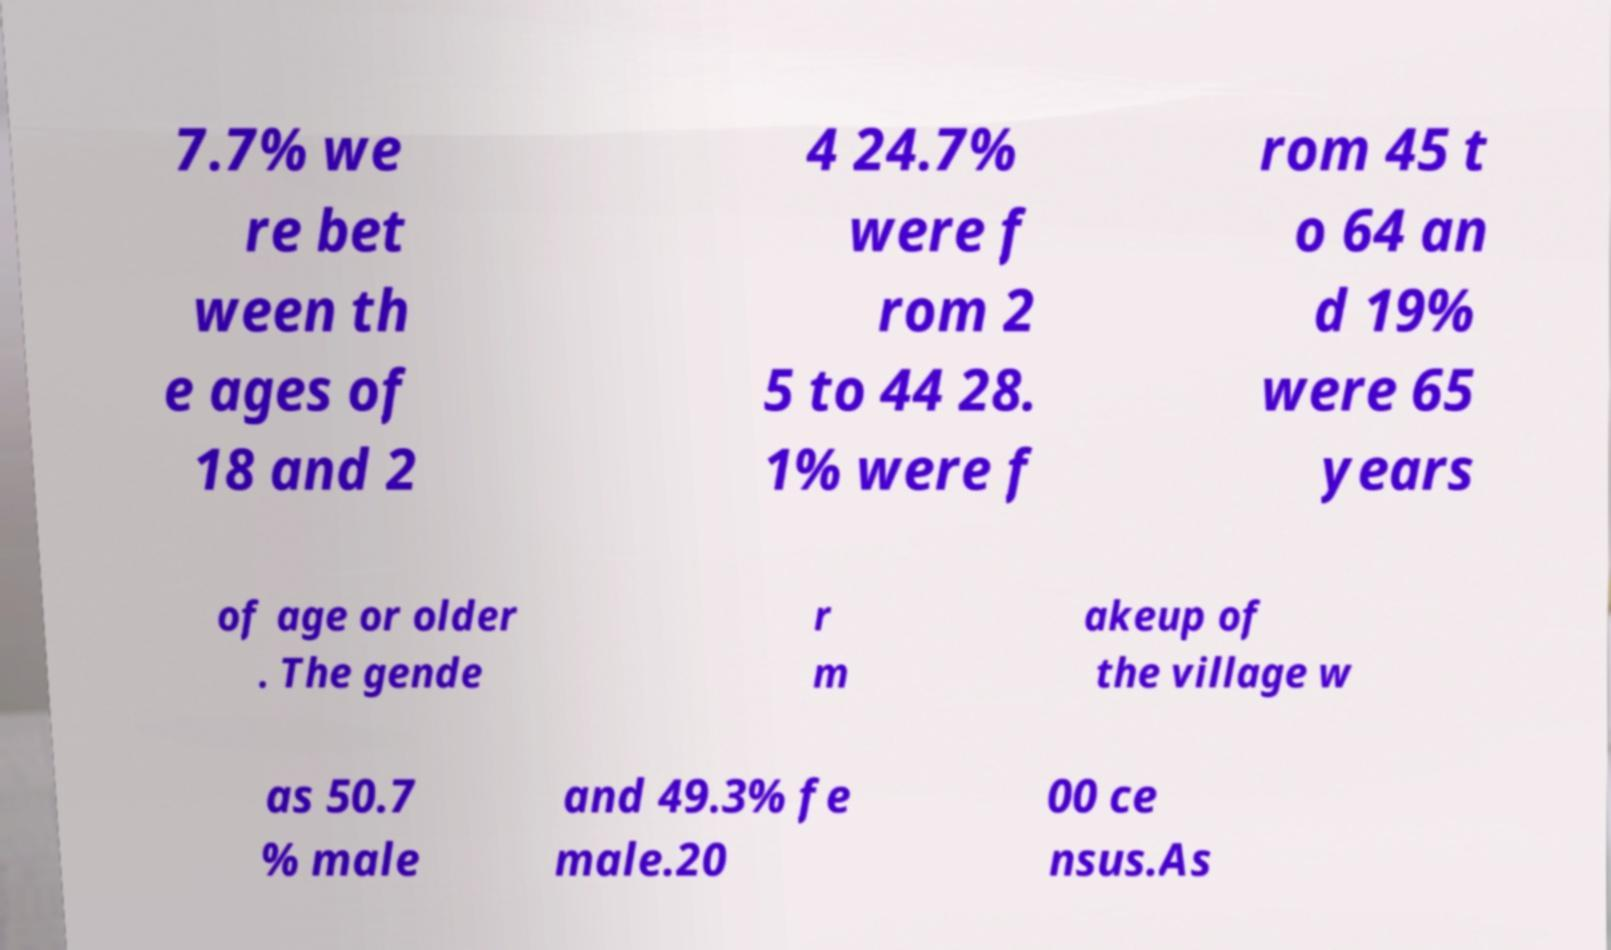Please identify and transcribe the text found in this image. 7.7% we re bet ween th e ages of 18 and 2 4 24.7% were f rom 2 5 to 44 28. 1% were f rom 45 t o 64 an d 19% were 65 years of age or older . The gende r m akeup of the village w as 50.7 % male and 49.3% fe male.20 00 ce nsus.As 